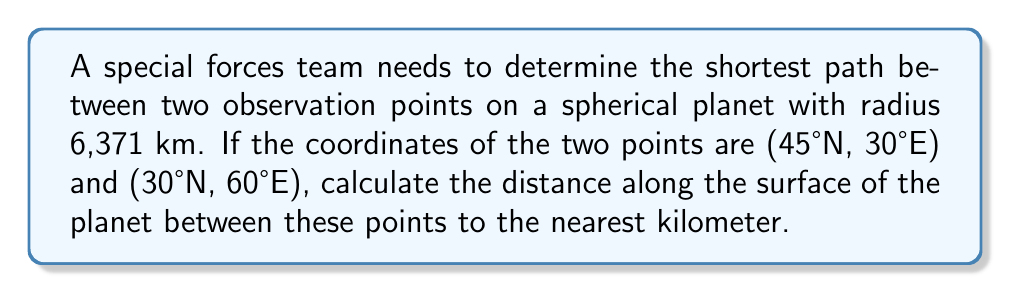Can you solve this math problem? To solve this problem, we'll use the Haversine formula, which calculates the great-circle distance between two points on a sphere given their latitudes and longitudes.

Step 1: Convert the coordinates to radians.
Let $\phi_1, \lambda_1$ be the latitude and longitude of point 1, and $\phi_2, \lambda_2$ be the latitude and longitude of point 2.

$\phi_1 = 45° \cdot \frac{\pi}{180} = 0.7854$ radians
$\lambda_1 = 30° \cdot \frac{\pi}{180} = 0.5236$ radians
$\phi_2 = 30° \cdot \frac{\pi}{180} = 0.5236$ radians
$\lambda_2 = 60° \cdot \frac{\pi}{180} = 1.0472$ radians

Step 2: Calculate the difference in longitude.
$\Delta\lambda = \lambda_2 - \lambda_1 = 1.0472 - 0.5236 = 0.5236$ radians

Step 3: Apply the Haversine formula.
$$\text{haversine}(\theta) = \sin^2(\frac{\theta}{2})$$
$$a = \text{haversine}(\phi_2 - \phi_1) + \cos(\phi_1) \cos(\phi_2) \text{haversine}(\Delta\lambda)$$

$$a = \sin^2(\frac{0.5236 - 0.7854}{2}) + \cos(0.7854) \cos(0.5236) \sin^2(\frac{0.5236}{2})$$

$$a = 0.0359$$

Step 4: Calculate the central angle.
$$\theta = 2 \arcsin(\sqrt{a})$$
$$\theta = 2 \arcsin(\sqrt{0.0359}) = 0.3799 \text{ radians}$$

Step 5: Calculate the distance.
$$d = R \theta$$
Where $R$ is the radius of the planet (6,371 km).

$$d = 6371 \cdot 0.3799 = 2420.34 \text{ km}$$

Step 6: Round to the nearest kilometer.
$d \approx 2420 \text{ km}$
Answer: 2420 km 